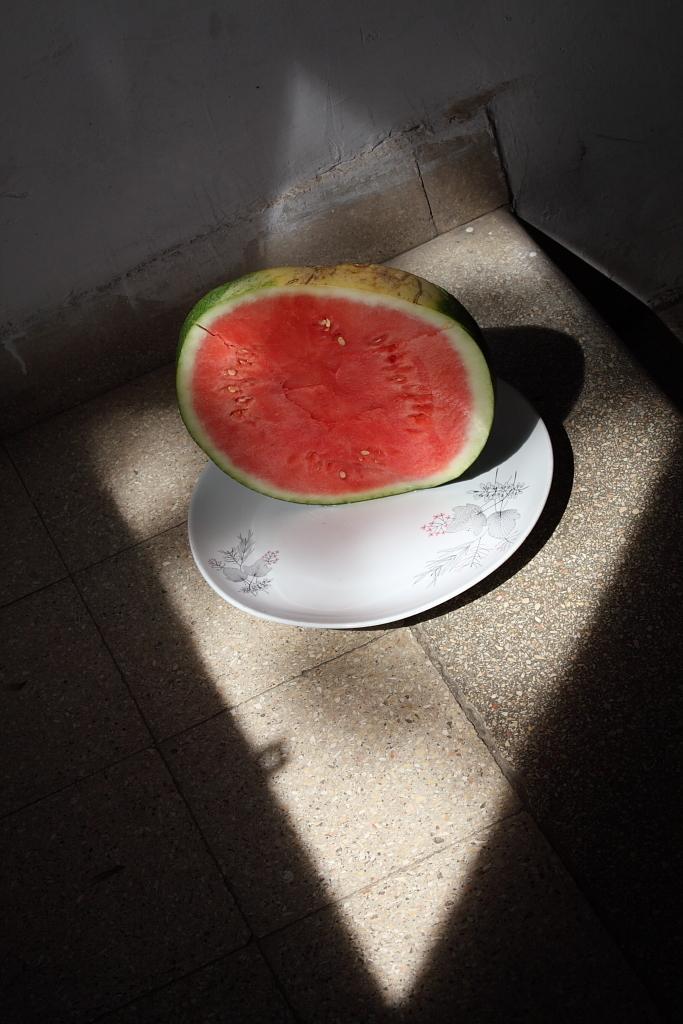Could you give a brief overview of what you see in this image? In the foreground of this image, there is a cut fruit on a platter which is placed on the surface. At the top, there is the wall. 